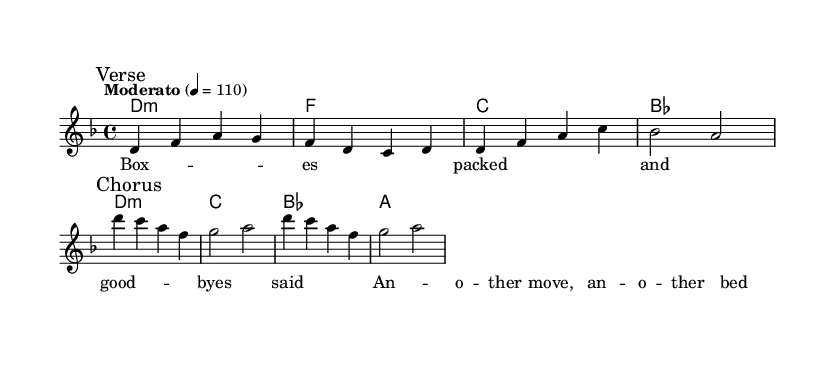What is the key signature of this music? The key signature is D minor, which has one flat (B flat). You can identify the key signature by looking at the beginning of the staff where sharps or flats are placed.
Answer: D minor What is the time signature of this music? The time signature is 4/4, which indicates there are four beats in a measure and the quarter note gets one beat. This is found at the beginning of the piece next to the key signature.
Answer: 4/4 What is the tempo marking of this music? The tempo marking indicates a speed of "Moderato" at 110 beats per minute. This instruction is shown at the start of the score to guide the performance speed.
Answer: Moderato 4 = 110 What are the two main sections of the piece? The two main sections indicated in the music are labeled "Verse" and "Chorus." These sections are marked clearly in the score to guide the performer in understanding the structure of the music.
Answer: Verse and Chorus How many measures are in the chorus? The chorus contains four measures. You can count the measures in the section marked "Chorus." Each measure is typically separated by vertical lines in the staff.
Answer: 4 What is the mood expressed in the lyrics of the verse? The mood expressed in the lyrics of the verse suggests feelings of transition and nostalgia, reflecting on moving and goodbyes. Analyzing the lyrics helps capture the emotional context and themes of the music.
Answer: Transition and nostalgia What is the primary theme of the chorus? The primary theme of the chorus emphasizes the idea of constant movement and the concept of 'home' being wherever the people are at that moment. The lyrics' content features this central idea, linking to the challenges of relocation.
Answer: Constant movement and home 